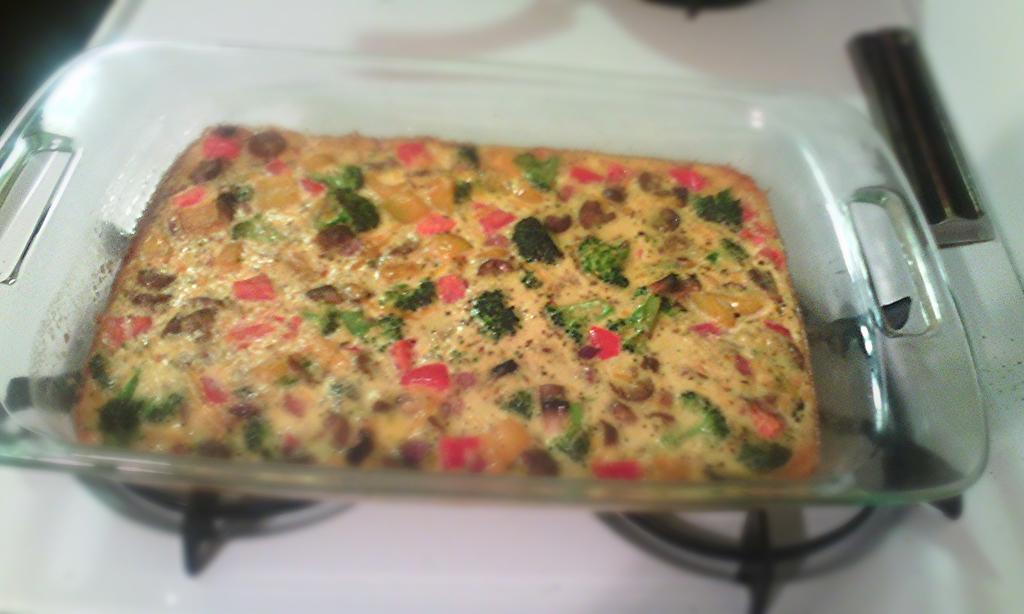Describe this image in one or two sentences. In this image in the center there is a tray, in the tray there is some food and at the bottom there is stove. 